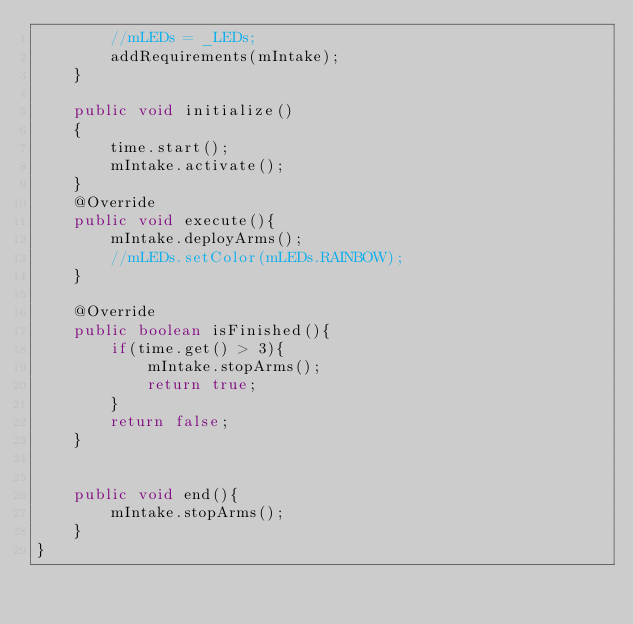<code> <loc_0><loc_0><loc_500><loc_500><_Java_>        //mLEDs = _LEDs;
        addRequirements(mIntake);
    }

    public void initialize()
    {
        time.start();
        mIntake.activate();
    }
    @Override
    public void execute(){
        mIntake.deployArms();
        //mLEDs.setColor(mLEDs.RAINBOW);
    }

    @Override
    public boolean isFinished(){
        if(time.get() > 3){
            mIntake.stopArms();
            return true;
        }
        return false;
    }


    public void end(){
        mIntake.stopArms();
    }
}</code> 